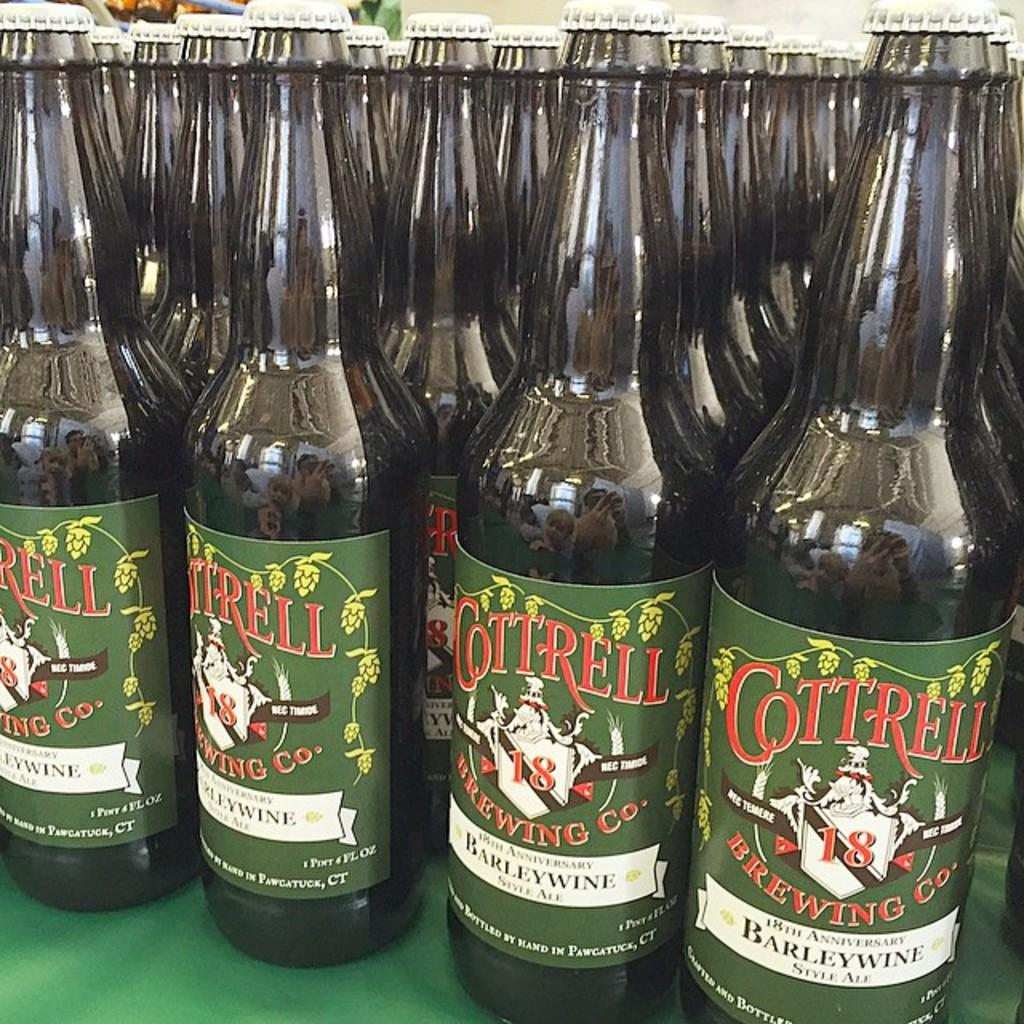<image>
Provide a brief description of the given image. Beer bottles that have a label saying Cottrell on it. 